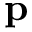<formula> <loc_0><loc_0><loc_500><loc_500>p</formula> 